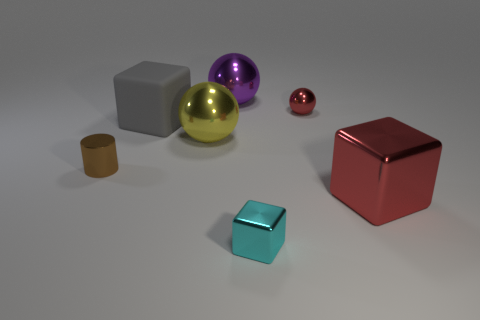What color is the tiny block?
Provide a short and direct response. Cyan. Is the color of the small shiny thing that is behind the cylinder the same as the large thing that is right of the big purple shiny sphere?
Make the answer very short. Yes. The cyan thing that is the same shape as the big gray object is what size?
Ensure brevity in your answer.  Small. Is there a object that has the same color as the large metallic block?
Keep it short and to the point. Yes. There is a tiny object that is the same color as the big shiny cube; what is it made of?
Provide a short and direct response. Metal. How many metallic spheres are the same color as the large metallic cube?
Offer a terse response. 1. What number of objects are cubes in front of the red cube or gray cubes?
Ensure brevity in your answer.  2. There is a tiny ball that is made of the same material as the tiny brown cylinder; what is its color?
Your answer should be compact. Red. Is there a gray matte cube of the same size as the brown metallic object?
Offer a terse response. No. How many things are large cubes that are on the right side of the tiny cyan cube or balls that are to the left of the large purple thing?
Provide a succinct answer. 2. 